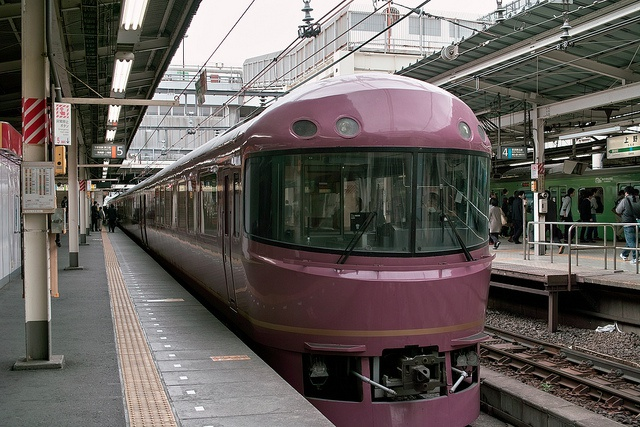Describe the objects in this image and their specific colors. I can see train in black, gray, maroon, and brown tones, train in black and darkgreen tones, people in black, gray, purple, and darkgray tones, train in black, gray, and darkgray tones, and people in black and gray tones in this image. 